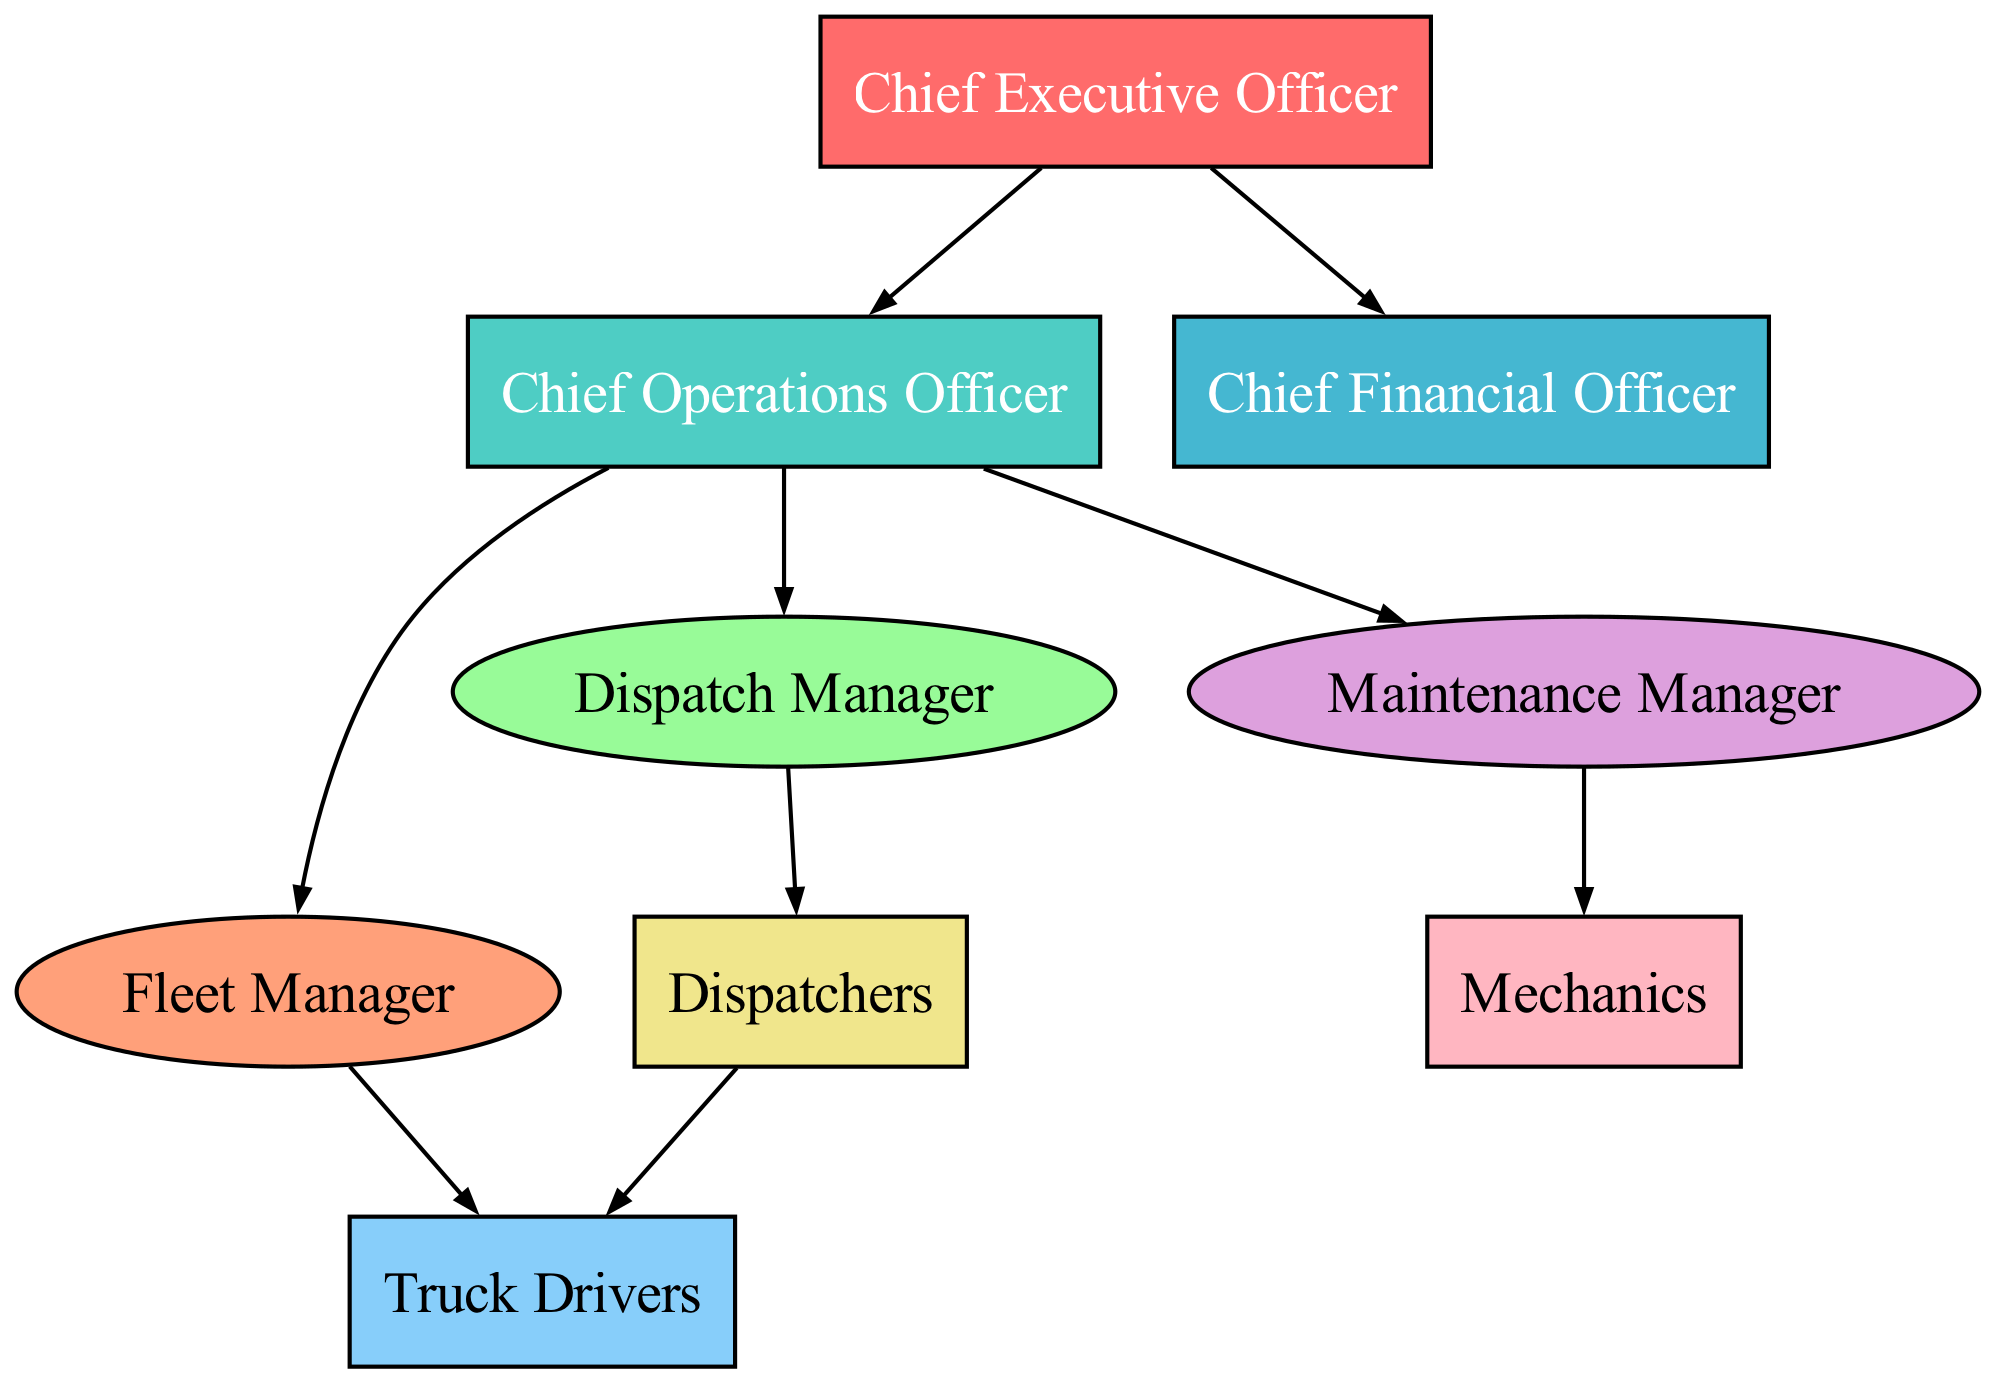What is the top position in the organizational structure? The highest node in the hierarchy is labeled "Chief Executive Officer," indicating that this is the top position within the organizational structure of the trucking company.
Answer: Chief Executive Officer How many managers report directly to the CEO? From the diagram, there are three direct reports to the CEO: the Chief Operations Officer, the Chief Financial Officer, and there are no other direct reports listed in the diagram.
Answer: 2 Which position oversees the drivers? The diagram shows that the Fleet Manager has a direct connection to the drivers, indicating that the Fleet Manager oversees this group.
Answer: Fleet Manager What color represents the Chief Operations Officer? In the diagram, the Chief Operations Officer is represented by a specific color which is denoted as '#4ECDC4,' and it corresponds to the unique fill color for this position.
Answer: #4ECDC4 Who do the Dispatchers report to? The Dispatchers have a direct connection to the Dispatch Manager. This means that their reporting line goes directly to the Dispatch Manager, making this the position they report to.
Answer: Dispatch Manager What role is responsible for maintenance? The Maintenance Manager is the position responsible for maintenance, as indicated by the direct connection from the COO to the Maintenance Manager within the organizational structure.
Answer: Maintenance Manager How many distinct nodes are there in the diagram? By counting all unique positions listed in the nodes section of the diagram, we find there are nine distinct nodes, representing the various roles within the company.
Answer: 9 How are the Drivers connected to the Dispatchers? The diagram shows a directional edge from Dispatchers to Drivers, indicating that the Dispatchers have a supervisory or support role over the drivers in their operational activities.
Answer: From Dispatchers to Drivers Which two roles are connected to the COO? The COO has two roles reporting to them: the Fleet Manager and the Dispatch Manager, both of which indicate the operational structure under the COO's responsibility.
Answer: Fleet Manager and Dispatch Manager 